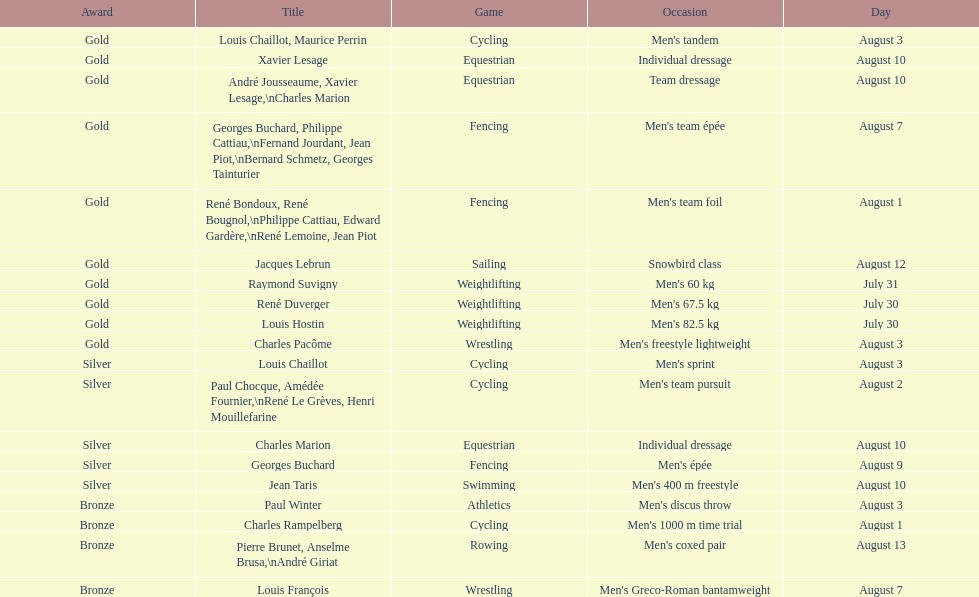How many gold medals did this country win during these olympics? 10. 